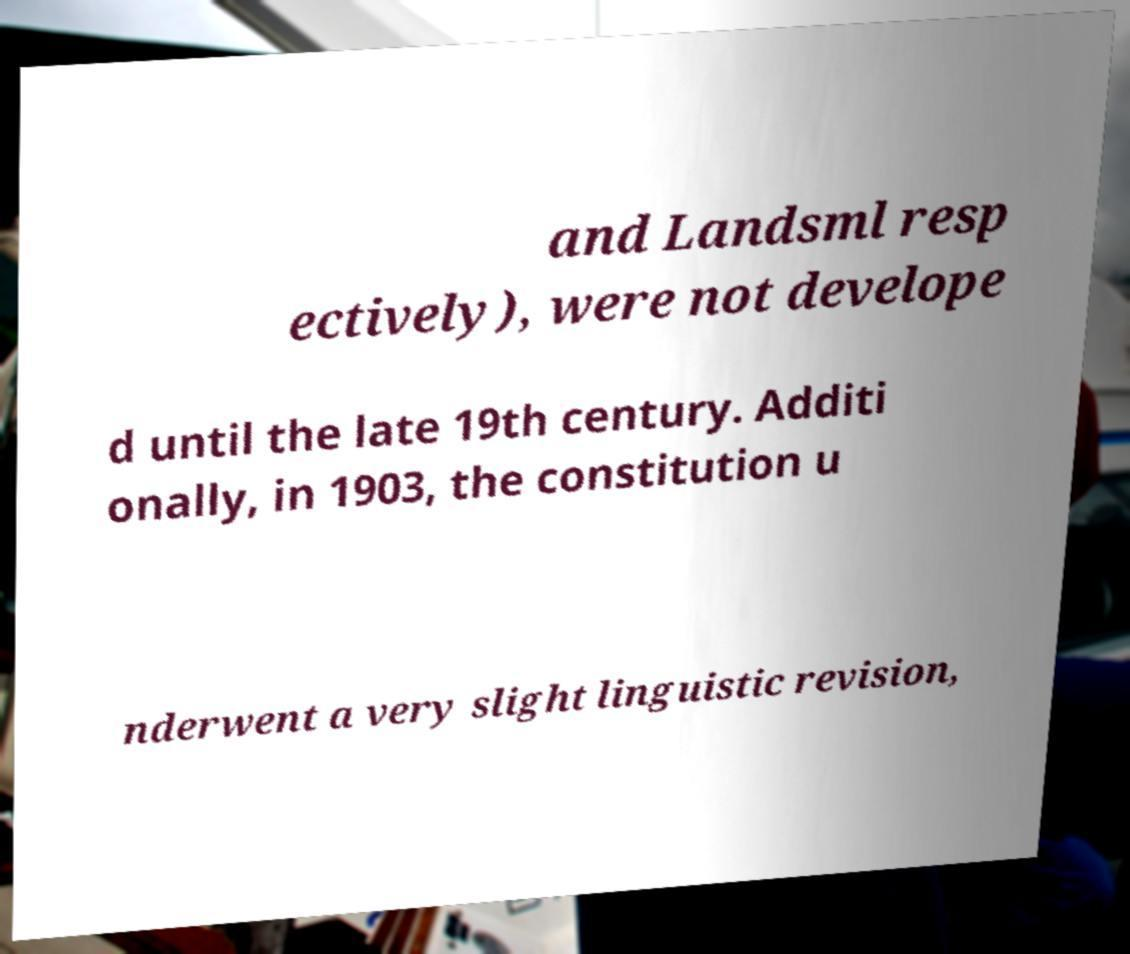I need the written content from this picture converted into text. Can you do that? and Landsml resp ectively), were not develope d until the late 19th century. Additi onally, in 1903, the constitution u nderwent a very slight linguistic revision, 